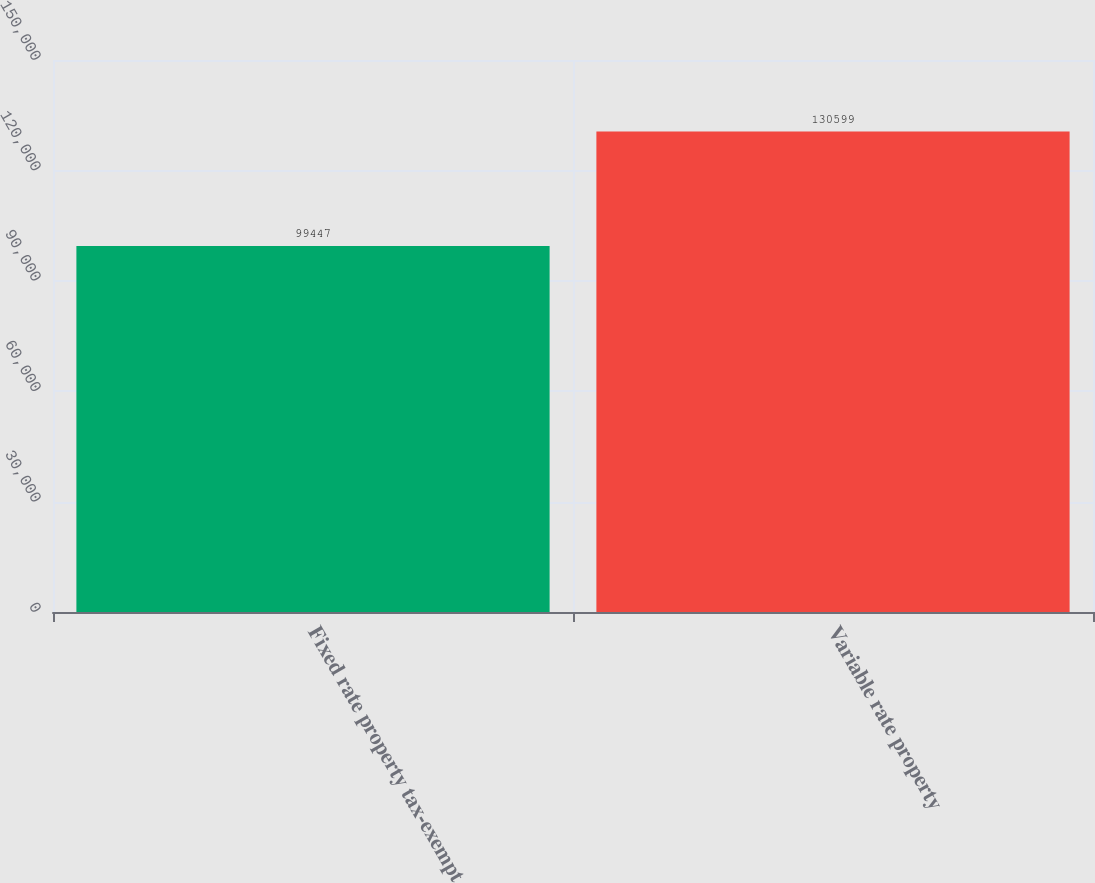<chart> <loc_0><loc_0><loc_500><loc_500><bar_chart><fcel>Fixed rate property tax-exempt<fcel>Variable rate property<nl><fcel>99447<fcel>130599<nl></chart> 